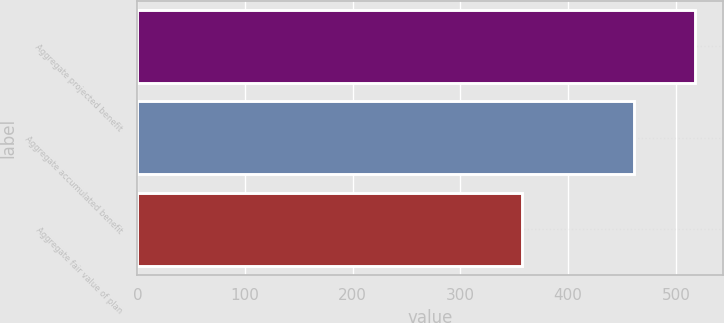<chart> <loc_0><loc_0><loc_500><loc_500><bar_chart><fcel>Aggregate projected benefit<fcel>Aggregate accumulated benefit<fcel>Aggregate fair value of plan<nl><fcel>518.1<fcel>461.5<fcel>357.4<nl></chart> 